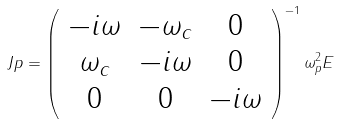Convert formula to latex. <formula><loc_0><loc_0><loc_500><loc_500>\ J p = \left ( \begin{array} { c c c } - i \omega & - \omega _ { c } & 0 \\ \omega _ { c } & - i \omega & 0 \\ 0 & 0 & - i \omega \end{array} \right ) ^ { - 1 } \omega _ { p } ^ { 2 } { E }</formula> 